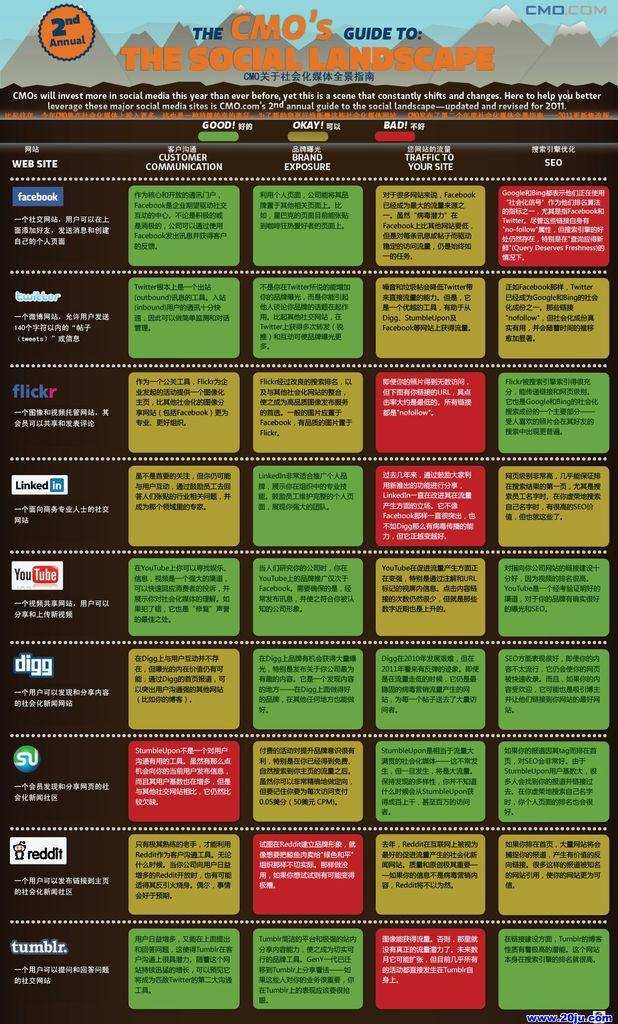<image>
Share a concise interpretation of the image provided. A poster of 'The CMO's guide to the social landscape'. 